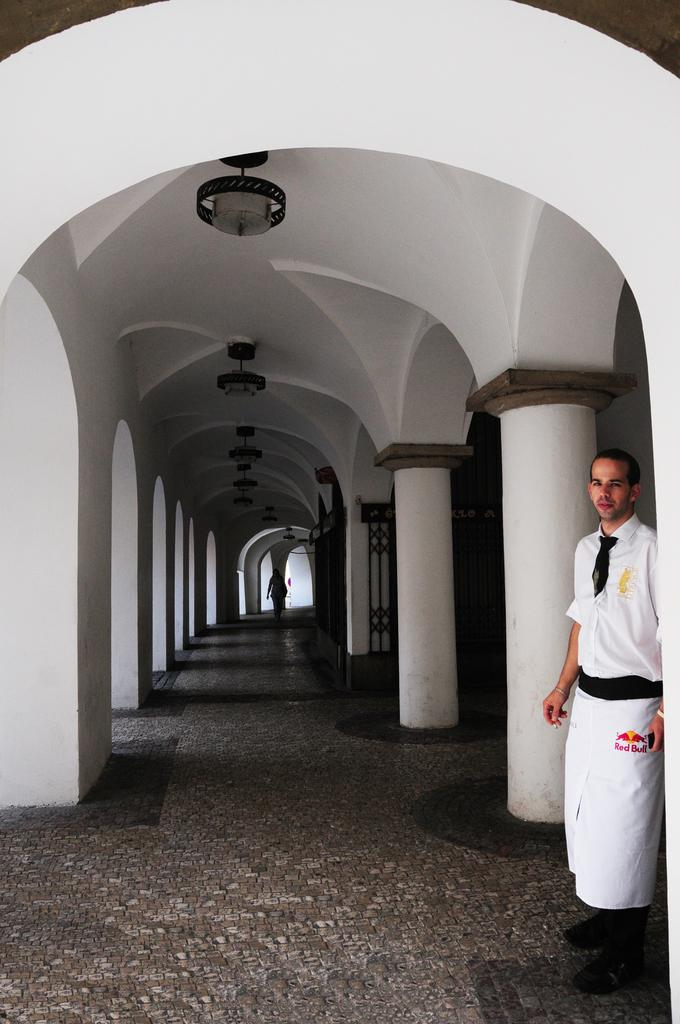How many people are present in the image? There are two persons standing in the image. What architectural features can be seen in the image? There are pillars in the image. What type of illumination is present in the image? There are lights in the image. How does the boot help the person in the image to rest? There is no boot present in the image, and therefore no such assistance can be observed. 